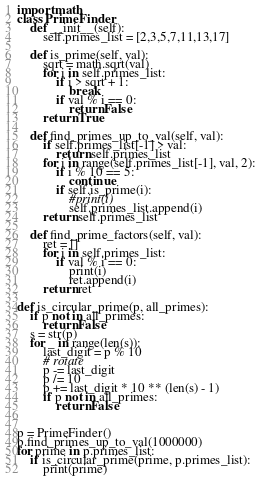<code> <loc_0><loc_0><loc_500><loc_500><_Python_>import math
class PrimeFinder:
    def __init__(self):
        self.primes_list = [2,3,5,7,11,13,17]

    def is_prime(self, val):
        sqrt = math.sqrt(val)
        for i in self.primes_list:
            if i > sqrt + 1:
                break
            if val % i == 0:
                return False
        return True

    def find_primes_up_to_val(self, val):
        if self.primes_list[-1] > val:
            return self.primes_list
        for i in range(self.primes_list[-1], val, 2):
            if i % 10 == 5:
                continue
            if self.is_prime(i):
                #print(i)
                self.primes_list.append(i)
        return self.primes_list

    def find_prime_factors(self, val):
        ret = []
        for i in self.primes_list:
            if val % i == 0:
                print(i)
                ret.append(i)
        return ret

def is_circular_prime(p, all_primes):
    if p not in all_primes:
        return False
    s = str(p)
    for _ in range(len(s)):
        last_digit = p % 10
        # rotate
        p -= last_digit
        p /= 10
        p += last_digit * 10 ** (len(s) - 1)
        if p not in all_primes:
            return False


p = PrimeFinder()
p.find_primes_up_to_val(1000000)
for prime in p.primes_list:
    if is_circular_prime(prime, p.primes_list):
        print(prime)</code> 